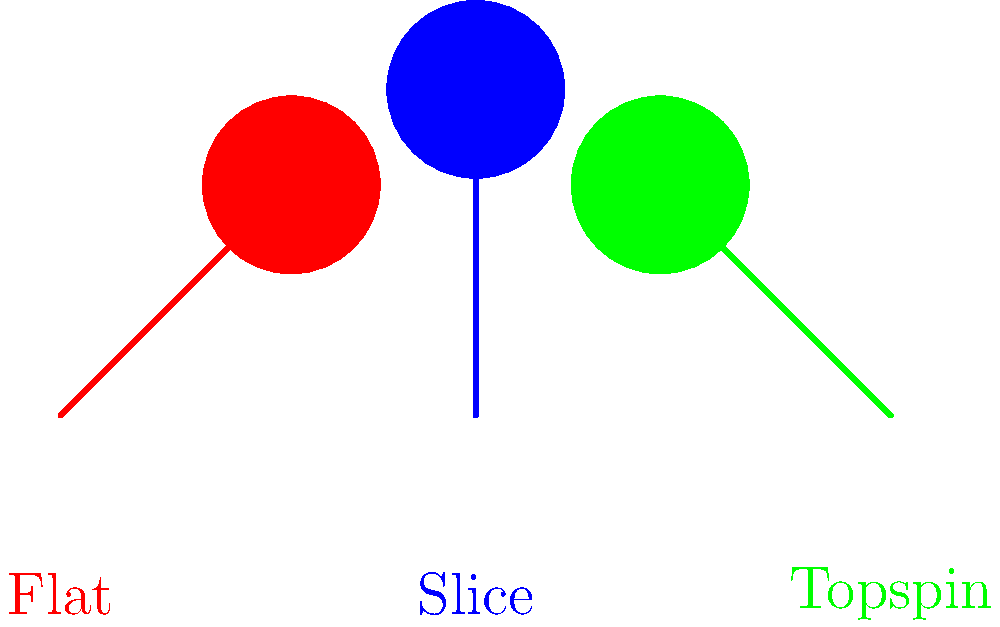As a tennis journalist, you're analyzing the mechanics of different serve types. The diagram shows simplified arm and racket positions for three common serves in tennis. Which serve type is most likely to generate the highest ball speed off the racket, and why? To answer this question, let's analyze each serve type:

1. Flat serve (red):
   - Arm angle is approximately 45 degrees
   - Racket face is perpendicular to the arm
   - This serve aims for maximum speed with minimal spin

2. Slice serve (blue):
   - Arm is vertical (90 degrees)
   - Racket face is angled slightly
   - This serve sacrifices some speed for sideways spin

3. Topspin serve (green):
   - Arm angle is approximately 135 degrees
   - Racket face is angled to brush up the ball
   - This serve generates topspin at the cost of some speed

The flat serve is most likely to generate the highest ball speed off the racket because:

a) It has the most direct path to the ball, allowing for maximum energy transfer.
b) The racket face is perpendicular to the arm, which helps in hitting the ball cleanly.
c) There's minimal energy lost to generating spin, as the primary focus is on speed.
d) The arm angle (45 degrees) allows for a good combination of vertical and horizontal force components, optimizing the power output.

In contrast, the slice and topspin serves sacrifice some speed to impart spin on the ball, which affects their trajectory and bounce but reduces initial velocity.
Answer: Flat serve 